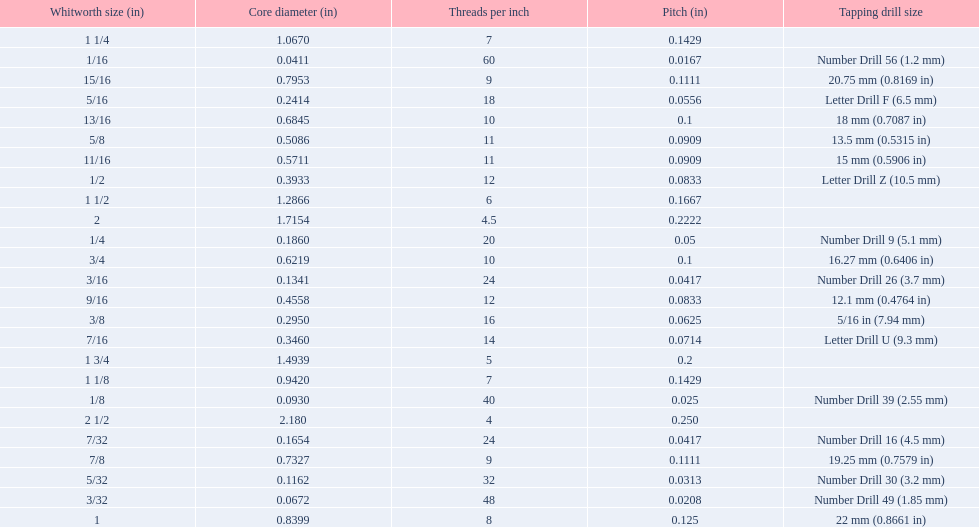What is the core diameter for the number drill 26? 0.1341. What is the whitworth size (in) for this core diameter? 3/16. 